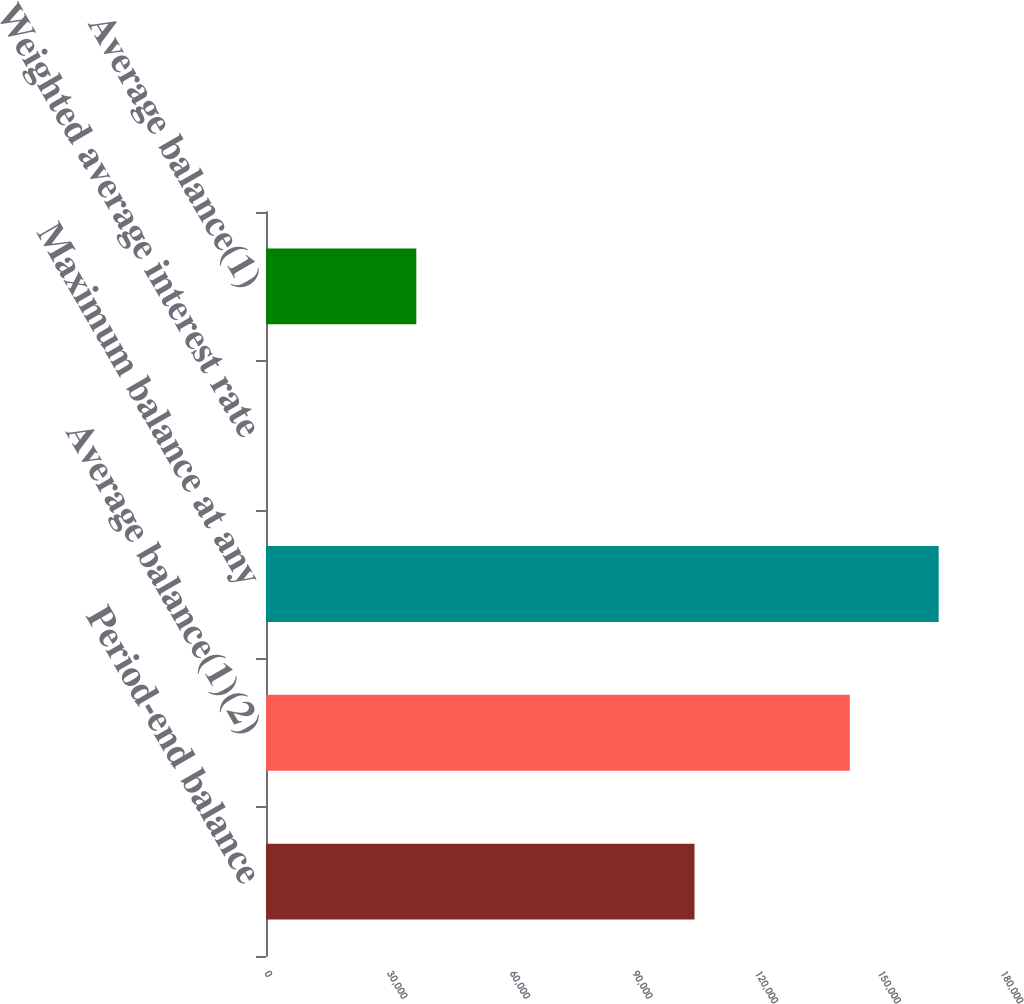Convert chart. <chart><loc_0><loc_0><loc_500><loc_500><bar_chart><fcel>Period-end balance<fcel>Average balance(1)(2)<fcel>Maximum balance at any<fcel>Weighted average interest rate<fcel>Average balance(1)<nl><fcel>104800<fcel>142784<fcel>164511<fcel>0.8<fcel>36762<nl></chart> 